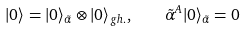Convert formula to latex. <formula><loc_0><loc_0><loc_500><loc_500>| 0 \rangle = | 0 \rangle _ { \tilde { \alpha } } \otimes | 0 \rangle _ { g h . } , \quad \tilde { \alpha } ^ { A } | 0 \rangle _ { \tilde { \alpha } } = 0</formula> 